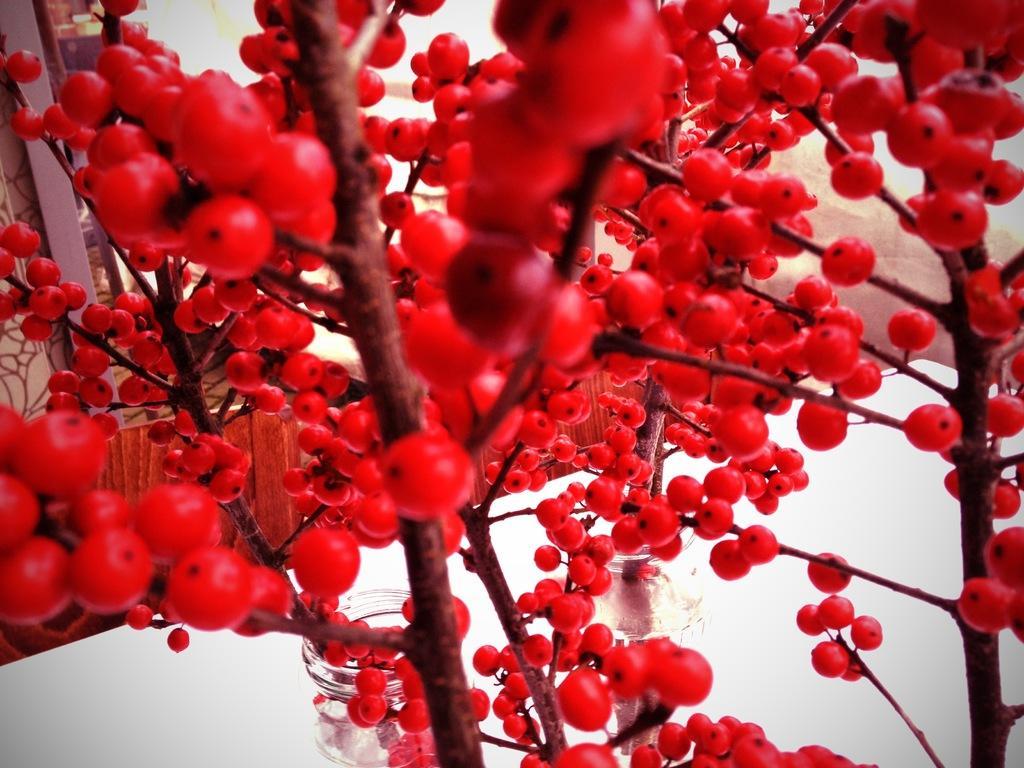In one or two sentences, can you explain what this image depicts? In this image we can see a tree with red color fruits. 